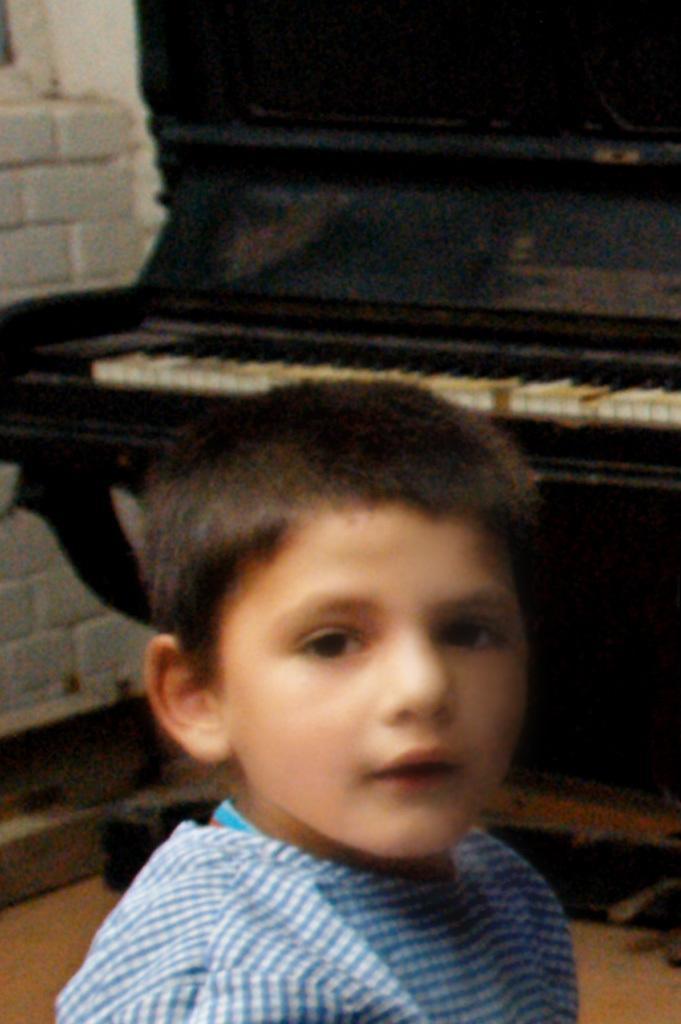Could you give a brief overview of what you see in this image? In this picture we can see boy and smiling and at back of him we can see piano, wall. 